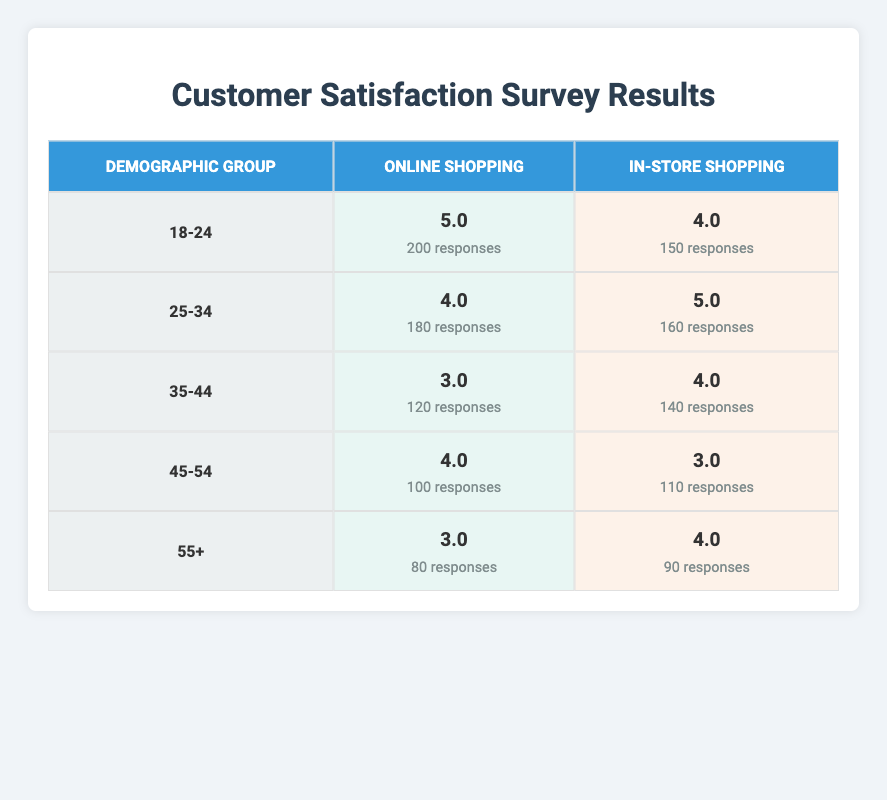What is the satisfaction score for the "In-Store Shopping" service among the 25-34 demographic group? The table shows that the satisfaction score for "In-Store Shopping" under the 25-34 demographic group is 5.0.
Answer: 5.0 How many responses were recorded for "Online Shopping" in the 18-24 demographic group? According to the table, there were 200 responses for "Online Shopping" in the 18-24 demographic group.
Answer: 200 What is the average satisfaction score for "Online Shopping" across all demographic groups? The satisfaction scores for "Online Shopping" are 5 (18-24), 4 (25-34), 3 (35-44), 4 (45-54), and 3 (55+). The total is 5 + 4 + 3 + 4 + 3 = 19. There are 5 groups, so the average is 19/5 = 3.8.
Answer: 3.8 Is the satisfaction score for "In-Store Shopping" higher than that for "Online Shopping" among the 35-44 demographic group? The satisfaction score for "In-Store Shopping" is 4.0 while for "Online Shopping" it is 3.0. Therefore, the score for "In-Store Shopping" is higher than that for "Online Shopping".
Answer: Yes Which demographic group has the highest satisfaction score for "Online Shopping", and what is that score? The demographic group "18-24" has the highest satisfaction score for "Online Shopping" at 5.0, as seen in the table.
Answer: 18-24, 5.0 What is the difference in the number of responses between "In-Store Shopping" and "Online Shopping" for the 45-54 age group? For the 45-54 age group, "In-Store Shopping" received 110 responses and "Online Shopping" received 100 responses. The difference is 110 - 100 = 10 responses.
Answer: 10 What is the overall trend of satisfaction scores for "Online Shopping" as the age demographic increases? The scores for "Online Shopping" by age group are: 5 (18-24), 4 (25-34), 3 (35-44), 4 (45-54), and 3 (55+). As we move to older age groups after the 25-34 demographic, we see a generally declining trend, with scores fluctuating (decreasing and then increasing slightly). Overall, there is a downward trend from 18-24 to 35-44 before stabilizing.
Answer: Generally declining trend How many total responses were collected for "In-Store Shopping"? The total number of responses for "In-Store Shopping" is the sum of all responses: 150 (18-24) + 160 (25-34) + 140 (35-44) + 110 (45-54) + 90 (55+) = 650 responses.
Answer: 650 